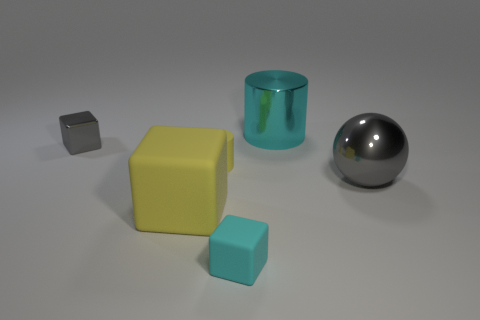Does the small yellow cylinder have the same material as the large object that is on the left side of the small cyan cube?
Provide a succinct answer. Yes. There is a cylinder that is in front of the cyan thing right of the tiny cyan rubber object; how big is it?
Your answer should be very brief. Small. Is the cyan object in front of the cyan metallic cylinder made of the same material as the cyan object that is right of the small cyan thing?
Give a very brief answer. No. The thing that is to the right of the cyan rubber cube and in front of the cyan shiny cylinder is made of what material?
Offer a very short reply. Metal. Is the shape of the big gray metal thing the same as the matte thing that is behind the big cube?
Offer a very short reply. No. What material is the big thing that is in front of the gray shiny thing in front of the gray thing on the left side of the cyan cube?
Provide a succinct answer. Rubber. How many other things are there of the same size as the cyan shiny object?
Provide a succinct answer. 2. Do the small shiny block and the big shiny ball have the same color?
Offer a very short reply. Yes. There is a big metal object that is in front of the tiny cube to the left of the big yellow block; how many things are left of it?
Keep it short and to the point. 5. The object on the left side of the large thing that is left of the cyan cylinder is made of what material?
Make the answer very short. Metal. 